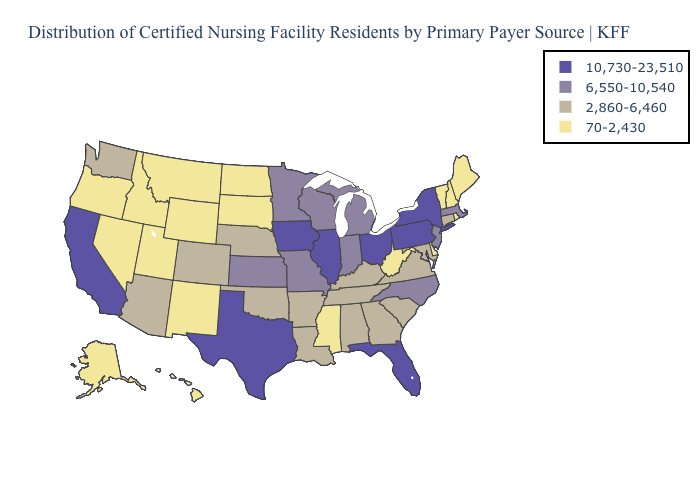What is the value of Nebraska?
Answer briefly. 2,860-6,460. What is the value of New Jersey?
Be succinct. 6,550-10,540. Is the legend a continuous bar?
Keep it brief. No. What is the lowest value in the MidWest?
Be succinct. 70-2,430. Which states have the lowest value in the USA?
Keep it brief. Alaska, Delaware, Hawaii, Idaho, Maine, Mississippi, Montana, Nevada, New Hampshire, New Mexico, North Dakota, Oregon, Rhode Island, South Dakota, Utah, Vermont, West Virginia, Wyoming. What is the value of Mississippi?
Write a very short answer. 70-2,430. What is the highest value in the MidWest ?
Concise answer only. 10,730-23,510. Name the states that have a value in the range 70-2,430?
Short answer required. Alaska, Delaware, Hawaii, Idaho, Maine, Mississippi, Montana, Nevada, New Hampshire, New Mexico, North Dakota, Oregon, Rhode Island, South Dakota, Utah, Vermont, West Virginia, Wyoming. What is the highest value in the South ?
Be succinct. 10,730-23,510. What is the value of Oregon?
Be succinct. 70-2,430. Name the states that have a value in the range 10,730-23,510?
Give a very brief answer. California, Florida, Illinois, Iowa, New York, Ohio, Pennsylvania, Texas. Does the map have missing data?
Give a very brief answer. No. How many symbols are there in the legend?
Be succinct. 4. Name the states that have a value in the range 6,550-10,540?
Give a very brief answer. Indiana, Kansas, Massachusetts, Michigan, Minnesota, Missouri, New Jersey, North Carolina, Wisconsin. 